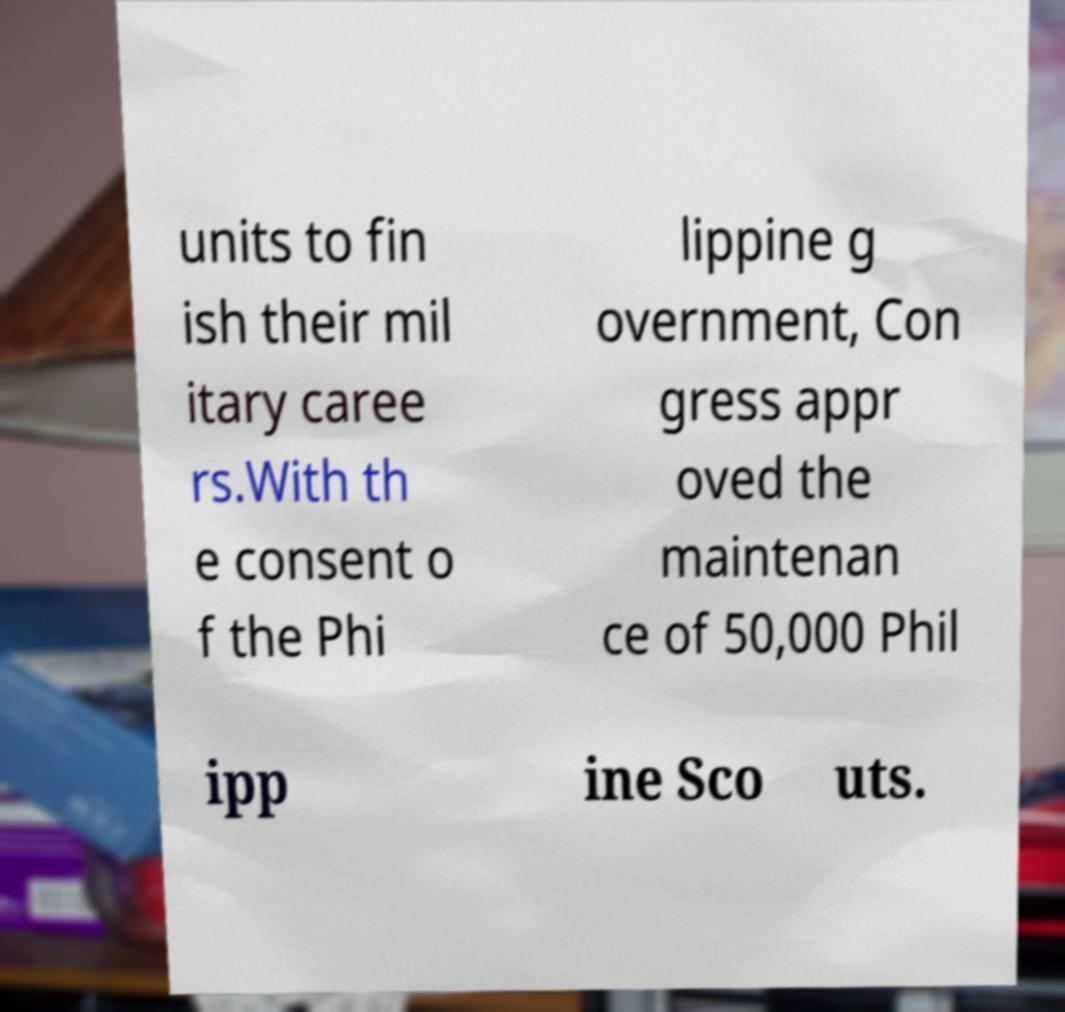Could you extract and type out the text from this image? units to fin ish their mil itary caree rs.With th e consent o f the Phi lippine g overnment, Con gress appr oved the maintenan ce of 50,000 Phil ipp ine Sco uts. 